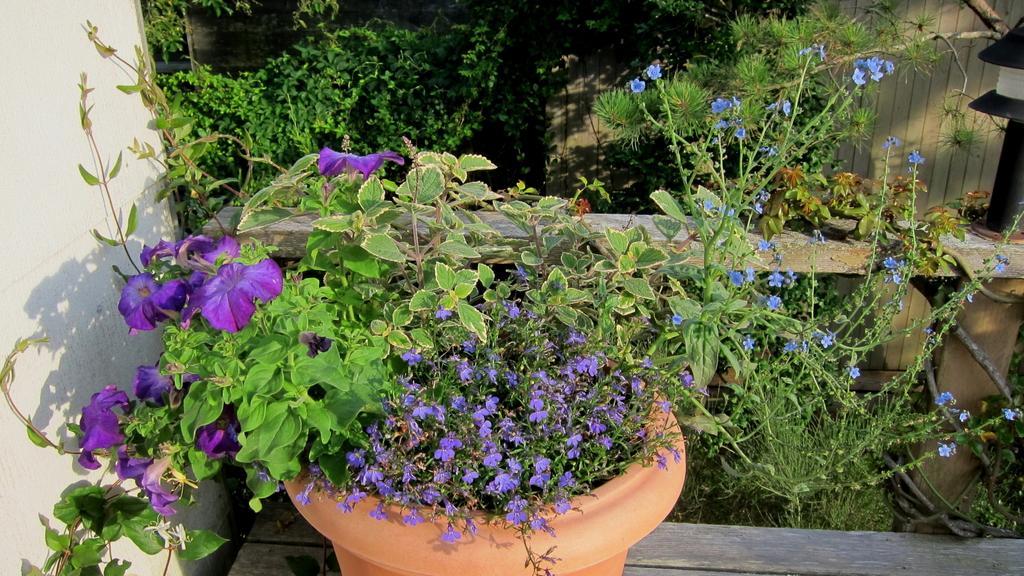Can you describe this image briefly? In this image we can see a flower pot placed on the bench and there are flowers. In the background there are bushes, fence and a wall. 